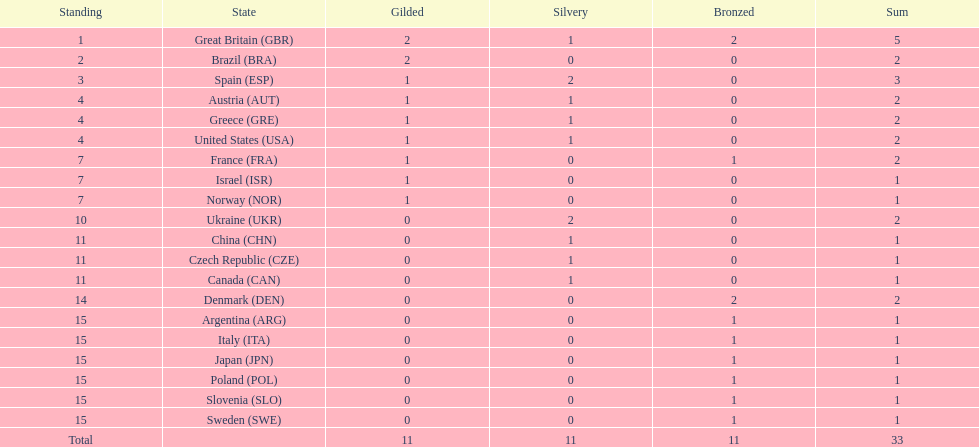How many countries won at least 2 medals in sailing? 9. 